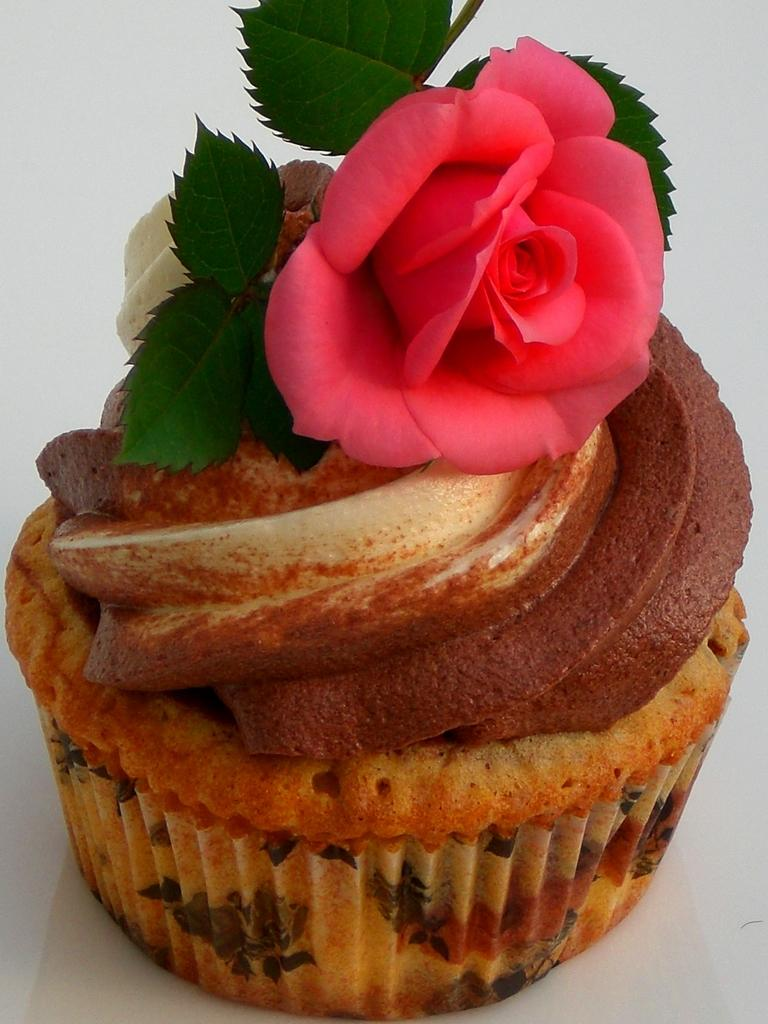What type of dessert is in the image? There is a cupcake in the image. What is the flavor of the cupcake? The cupcake has chocolate. What other object is present in the image? There is a pink colorful flower in the image. What can be observed about the flower's leaves? The flower has green leaves. What time does the clock in the image show? There is no clock present in the image. 